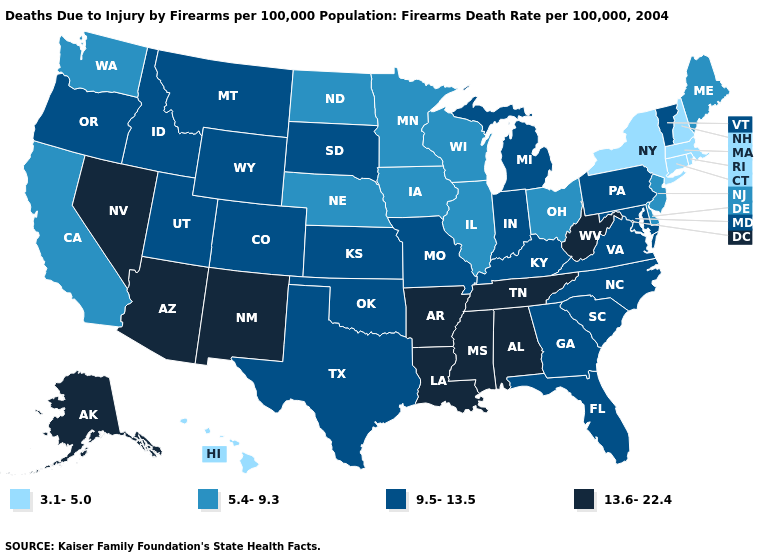What is the lowest value in the USA?
Be succinct. 3.1-5.0. What is the highest value in the West ?
Answer briefly. 13.6-22.4. Among the states that border Oklahoma , does Colorado have the highest value?
Quick response, please. No. Name the states that have a value in the range 3.1-5.0?
Keep it brief. Connecticut, Hawaii, Massachusetts, New Hampshire, New York, Rhode Island. Among the states that border Ohio , does Michigan have the highest value?
Quick response, please. No. What is the value of Michigan?
Keep it brief. 9.5-13.5. What is the highest value in the USA?
Concise answer only. 13.6-22.4. Does Wisconsin have the same value as Iowa?
Quick response, please. Yes. What is the value of New Jersey?
Keep it brief. 5.4-9.3. Name the states that have a value in the range 5.4-9.3?
Be succinct. California, Delaware, Illinois, Iowa, Maine, Minnesota, Nebraska, New Jersey, North Dakota, Ohio, Washington, Wisconsin. Name the states that have a value in the range 9.5-13.5?
Be succinct. Colorado, Florida, Georgia, Idaho, Indiana, Kansas, Kentucky, Maryland, Michigan, Missouri, Montana, North Carolina, Oklahoma, Oregon, Pennsylvania, South Carolina, South Dakota, Texas, Utah, Vermont, Virginia, Wyoming. Does New York have the lowest value in the USA?
Write a very short answer. Yes. What is the value of Hawaii?
Short answer required. 3.1-5.0. What is the lowest value in states that border Michigan?
Keep it brief. 5.4-9.3. Which states have the lowest value in the USA?
Short answer required. Connecticut, Hawaii, Massachusetts, New Hampshire, New York, Rhode Island. 